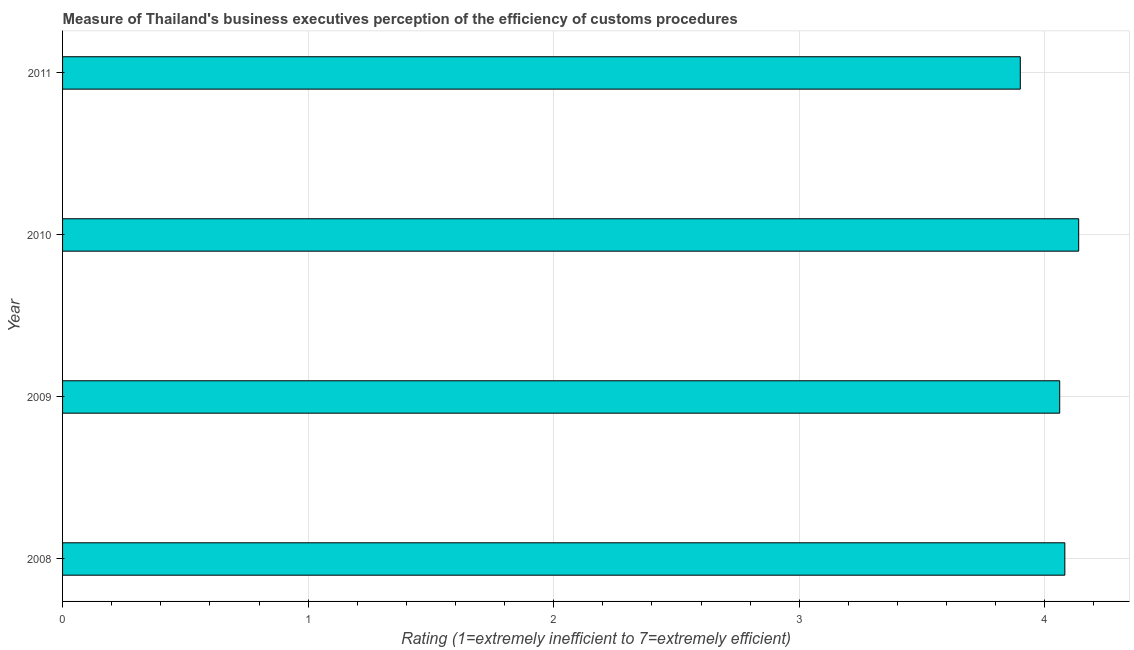Does the graph contain any zero values?
Your answer should be very brief. No. What is the title of the graph?
Offer a terse response. Measure of Thailand's business executives perception of the efficiency of customs procedures. What is the label or title of the X-axis?
Your response must be concise. Rating (1=extremely inefficient to 7=extremely efficient). What is the label or title of the Y-axis?
Your response must be concise. Year. What is the rating measuring burden of customs procedure in 2008?
Offer a terse response. 4.08. Across all years, what is the maximum rating measuring burden of customs procedure?
Ensure brevity in your answer.  4.14. Across all years, what is the minimum rating measuring burden of customs procedure?
Keep it short and to the point. 3.9. What is the sum of the rating measuring burden of customs procedure?
Provide a succinct answer. 16.18. What is the difference between the rating measuring burden of customs procedure in 2009 and 2011?
Provide a succinct answer. 0.16. What is the average rating measuring burden of customs procedure per year?
Your answer should be very brief. 4.04. What is the median rating measuring burden of customs procedure?
Offer a very short reply. 4.07. What is the ratio of the rating measuring burden of customs procedure in 2009 to that in 2011?
Your answer should be compact. 1.04. Is the rating measuring burden of customs procedure in 2008 less than that in 2011?
Provide a succinct answer. No. What is the difference between the highest and the second highest rating measuring burden of customs procedure?
Your answer should be very brief. 0.06. What is the difference between the highest and the lowest rating measuring burden of customs procedure?
Keep it short and to the point. 0.24. How many bars are there?
Give a very brief answer. 4. Are all the bars in the graph horizontal?
Make the answer very short. Yes. How many years are there in the graph?
Your answer should be compact. 4. What is the difference between two consecutive major ticks on the X-axis?
Your answer should be compact. 1. What is the Rating (1=extremely inefficient to 7=extremely efficient) of 2008?
Provide a succinct answer. 4.08. What is the Rating (1=extremely inefficient to 7=extremely efficient) in 2009?
Ensure brevity in your answer.  4.06. What is the Rating (1=extremely inefficient to 7=extremely efficient) in 2010?
Offer a very short reply. 4.14. What is the difference between the Rating (1=extremely inefficient to 7=extremely efficient) in 2008 and 2009?
Your response must be concise. 0.02. What is the difference between the Rating (1=extremely inefficient to 7=extremely efficient) in 2008 and 2010?
Offer a terse response. -0.06. What is the difference between the Rating (1=extremely inefficient to 7=extremely efficient) in 2008 and 2011?
Provide a succinct answer. 0.18. What is the difference between the Rating (1=extremely inefficient to 7=extremely efficient) in 2009 and 2010?
Provide a succinct answer. -0.08. What is the difference between the Rating (1=extremely inefficient to 7=extremely efficient) in 2009 and 2011?
Your answer should be compact. 0.16. What is the difference between the Rating (1=extremely inefficient to 7=extremely efficient) in 2010 and 2011?
Provide a short and direct response. 0.24. What is the ratio of the Rating (1=extremely inefficient to 7=extremely efficient) in 2008 to that in 2010?
Ensure brevity in your answer.  0.99. What is the ratio of the Rating (1=extremely inefficient to 7=extremely efficient) in 2008 to that in 2011?
Your answer should be very brief. 1.05. What is the ratio of the Rating (1=extremely inefficient to 7=extremely efficient) in 2009 to that in 2010?
Offer a very short reply. 0.98. What is the ratio of the Rating (1=extremely inefficient to 7=extremely efficient) in 2009 to that in 2011?
Your answer should be very brief. 1.04. What is the ratio of the Rating (1=extremely inefficient to 7=extremely efficient) in 2010 to that in 2011?
Provide a short and direct response. 1.06. 